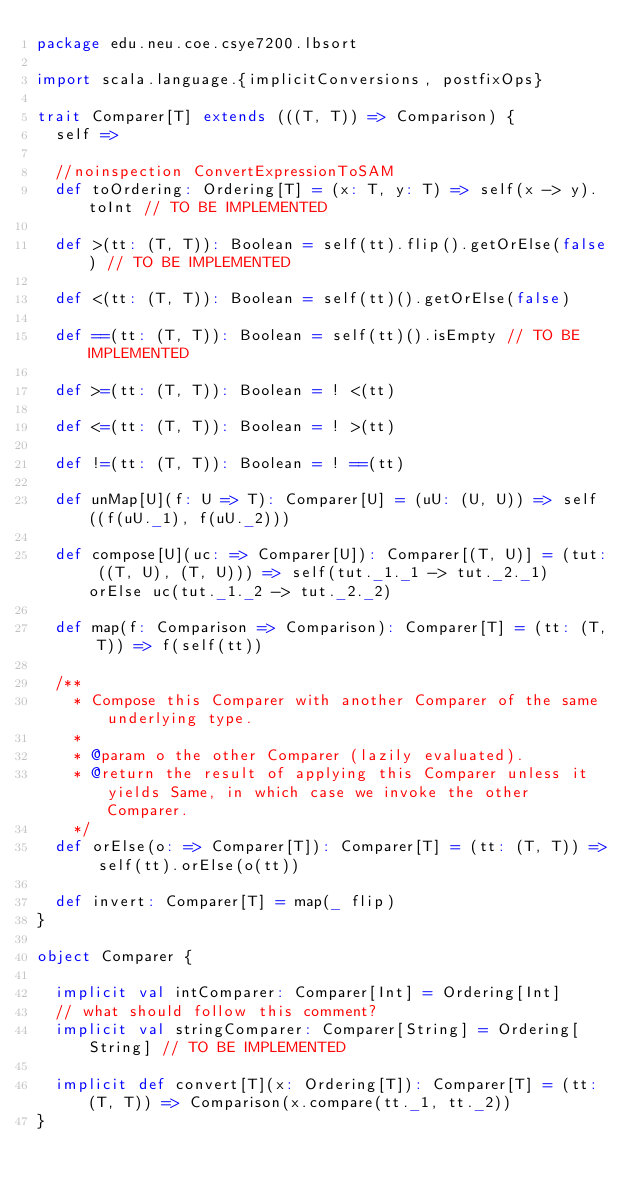<code> <loc_0><loc_0><loc_500><loc_500><_Scala_>package edu.neu.coe.csye7200.lbsort

import scala.language.{implicitConversions, postfixOps}

trait Comparer[T] extends (((T, T)) => Comparison) {
  self =>

  //noinspection ConvertExpressionToSAM
  def toOrdering: Ordering[T] = (x: T, y: T) => self(x -> y).toInt // TO BE IMPLEMENTED

  def >(tt: (T, T)): Boolean = self(tt).flip().getOrElse(false) // TO BE IMPLEMENTED

  def <(tt: (T, T)): Boolean = self(tt)().getOrElse(false)

  def ==(tt: (T, T)): Boolean = self(tt)().isEmpty // TO BE IMPLEMENTED

  def >=(tt: (T, T)): Boolean = ! <(tt)

  def <=(tt: (T, T)): Boolean = ! >(tt)

  def !=(tt: (T, T)): Boolean = ! ==(tt)

  def unMap[U](f: U => T): Comparer[U] = (uU: (U, U)) => self((f(uU._1), f(uU._2)))

  def compose[U](uc: => Comparer[U]): Comparer[(T, U)] = (tut: ((T, U), (T, U))) => self(tut._1._1 -> tut._2._1) orElse uc(tut._1._2 -> tut._2._2)

  def map(f: Comparison => Comparison): Comparer[T] = (tt: (T, T)) => f(self(tt))

  /**
    * Compose this Comparer with another Comparer of the same underlying type.
    *
    * @param o the other Comparer (lazily evaluated).
    * @return the result of applying this Comparer unless it yields Same, in which case we invoke the other Comparer.
    */
  def orElse(o: => Comparer[T]): Comparer[T] = (tt: (T, T)) => self(tt).orElse(o(tt))

  def invert: Comparer[T] = map(_ flip)
}

object Comparer {

  implicit val intComparer: Comparer[Int] = Ordering[Int]
  // what should follow this comment?
  implicit val stringComparer: Comparer[String] = Ordering[String] // TO BE IMPLEMENTED

  implicit def convert[T](x: Ordering[T]): Comparer[T] = (tt: (T, T)) => Comparison(x.compare(tt._1, tt._2))
}
</code> 